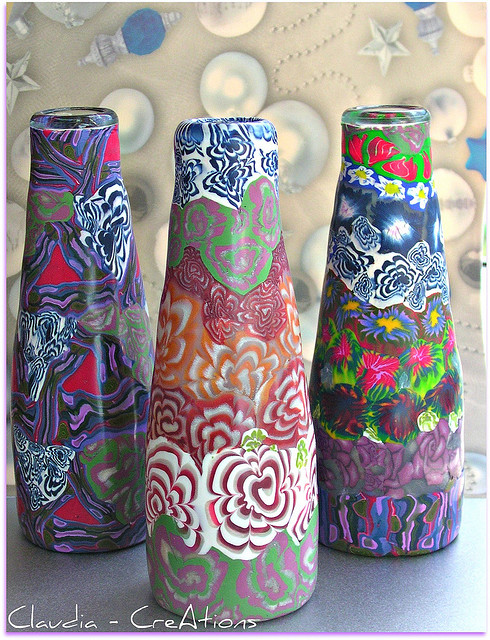Identify and read out the text in this image. Clavdia Cre Ations 